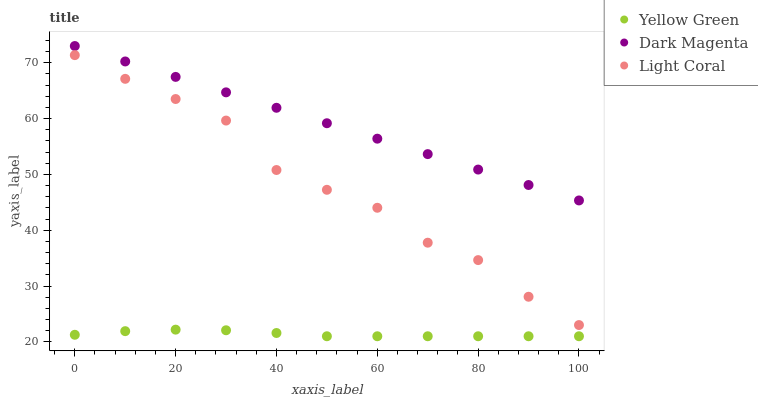Does Yellow Green have the minimum area under the curve?
Answer yes or no. Yes. Does Dark Magenta have the maximum area under the curve?
Answer yes or no. Yes. Does Dark Magenta have the minimum area under the curve?
Answer yes or no. No. Does Yellow Green have the maximum area under the curve?
Answer yes or no. No. Is Dark Magenta the smoothest?
Answer yes or no. Yes. Is Light Coral the roughest?
Answer yes or no. Yes. Is Yellow Green the smoothest?
Answer yes or no. No. Is Yellow Green the roughest?
Answer yes or no. No. Does Yellow Green have the lowest value?
Answer yes or no. Yes. Does Dark Magenta have the lowest value?
Answer yes or no. No. Does Dark Magenta have the highest value?
Answer yes or no. Yes. Does Yellow Green have the highest value?
Answer yes or no. No. Is Light Coral less than Dark Magenta?
Answer yes or no. Yes. Is Light Coral greater than Yellow Green?
Answer yes or no. Yes. Does Light Coral intersect Dark Magenta?
Answer yes or no. No. 